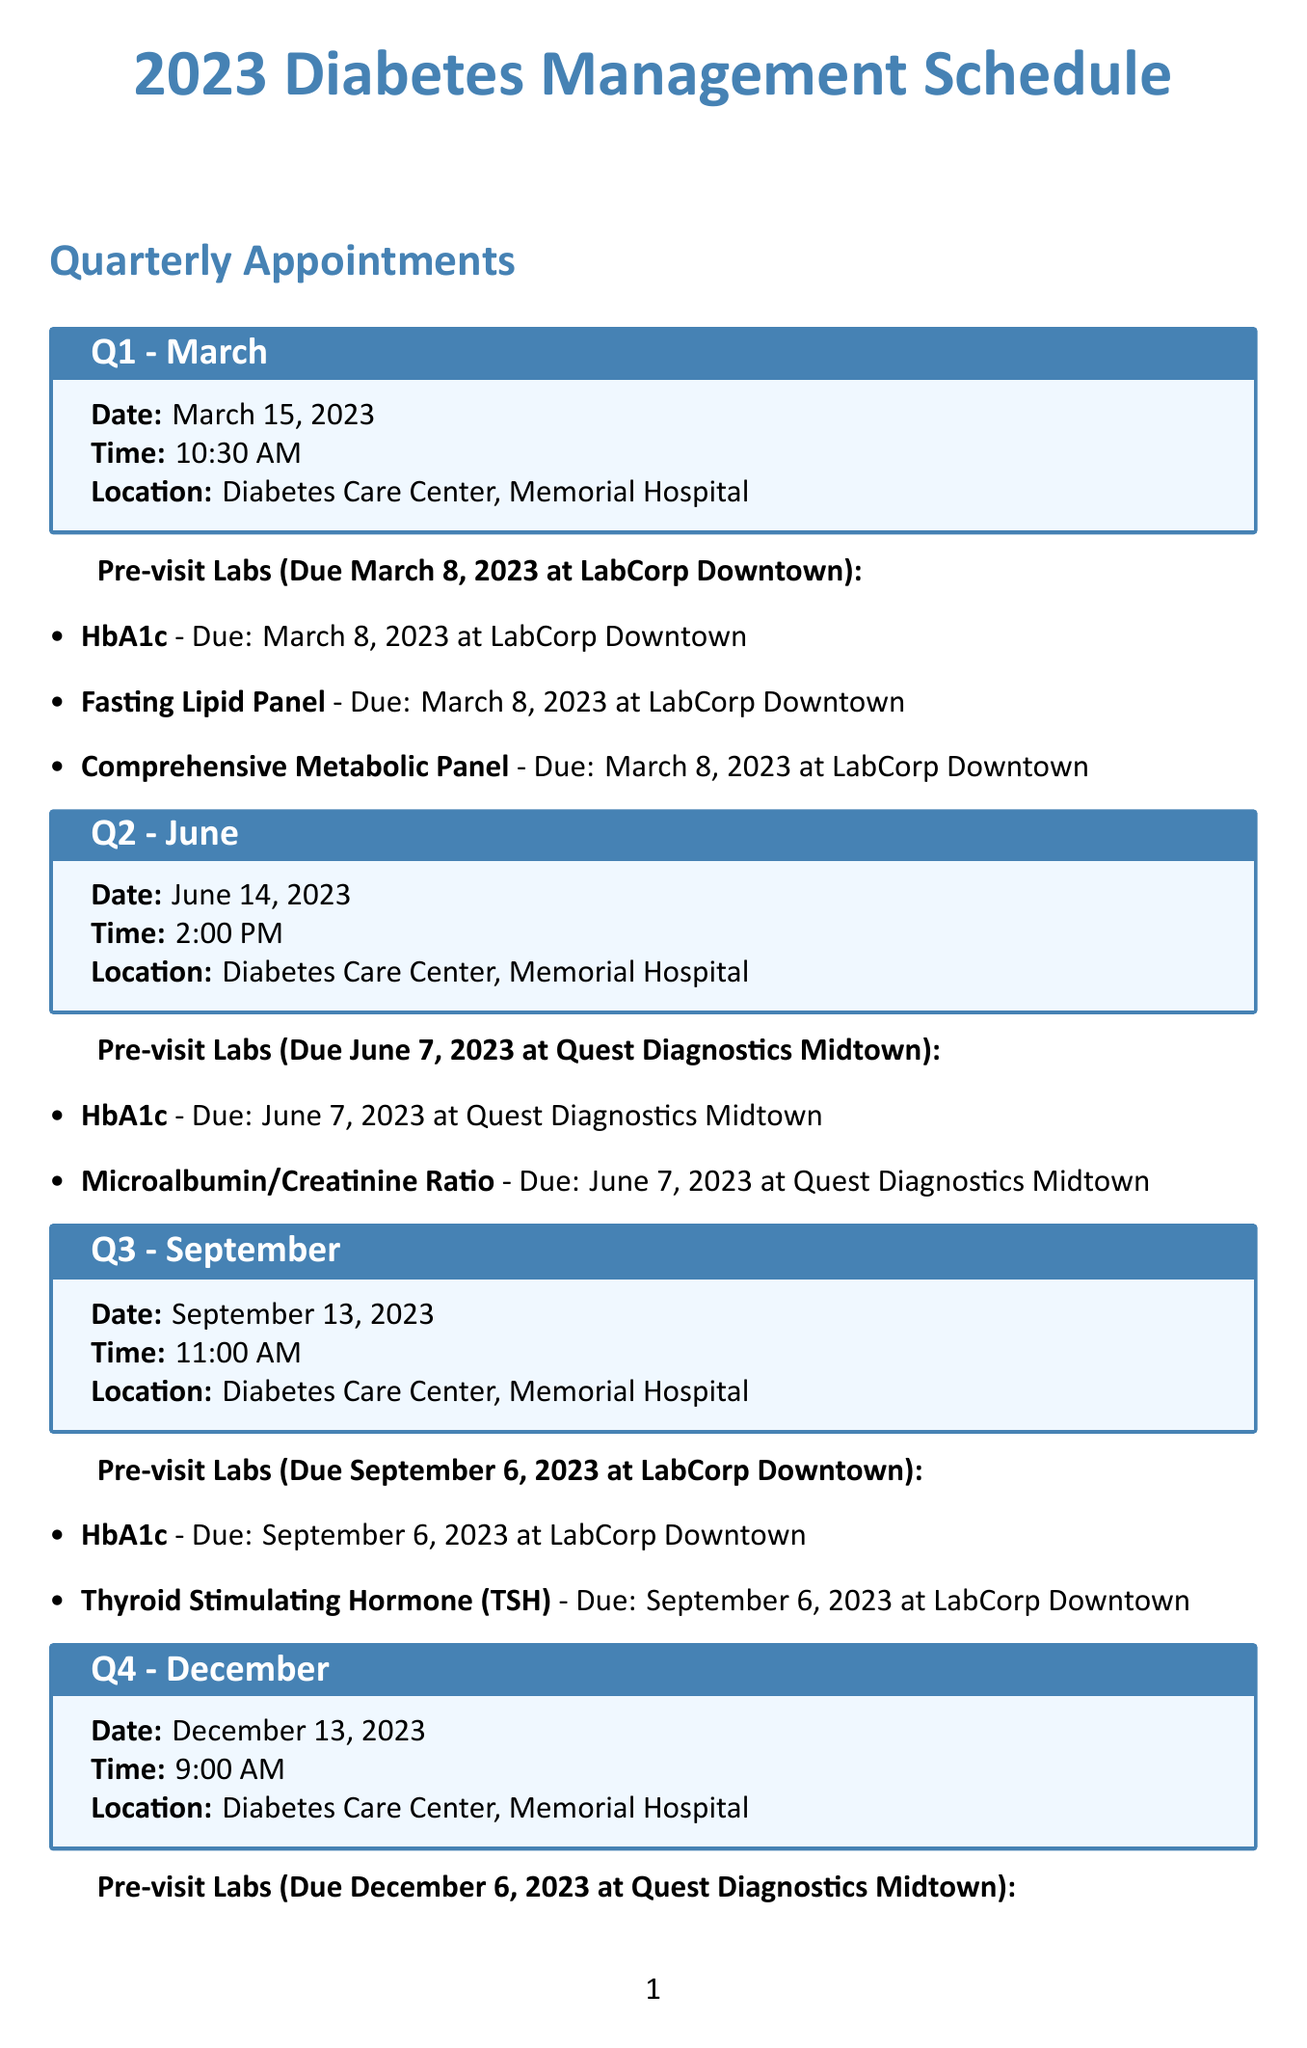what is the date of the Q1 appointment? The Q1 appointment is scheduled for March 15, 2023.
Answer: March 15, 2023 who is the doctor for all appointments listed? The document states that Dr. Sarah Johnson is the doctor for all scheduled appointments.
Answer: Dr. Sarah Johnson when is the due date for the HbA1c test in Q3? The HbA1c test for Q3 is due on September 6, 2023.
Answer: September 6, 2023 how many pre-visit labs are required for the Q4 appointment? The Q4 appointment requires four pre-visit labs as outlined in the document.
Answer: Four what is the topic of the diabetes education class? The document specifies that the topic is "Nutrition for Type 2 Diabetes."
Answer: Nutrition for Type 2 Diabetes when is the Comprehensive Foot Exam due? The Comprehensive Foot Exam is due on December 13, 2023, during the Q4 appointment.
Answer: December 13, 2023 at what time is the Q2 appointment scheduled? The document lists the time for the Q2 appointment as 2:00 PM.
Answer: 2:00 PM what location is the Q3 appointment taking place? The document states that the location for the Q3 appointment is "Diabetes Care Center, Memorial Hospital."
Answer: Diabetes Care Center, Memorial Hospital 